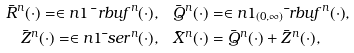Convert formula to latex. <formula><loc_0><loc_0><loc_500><loc_500>\bar { R } ^ { n } ( \cdot ) = \in n { 1 } { \bar { \ } r b u f ^ { n } ( \cdot ) } , & \quad \bar { Q } ^ { n } ( \cdot ) = \in n { 1 _ { ( 0 , \infty ) } } { \bar { \ } r b u f ^ { n } ( \cdot ) } , \\ \bar { Z } ^ { n } ( \cdot ) = \in n { 1 } { \bar { \ } s e r ^ { n } ( \cdot ) } , & \quad \bar { X } ^ { n } ( \cdot ) = \bar { Q } ^ { n } ( \cdot ) + \bar { Z } ^ { n } ( \cdot ) ,</formula> 